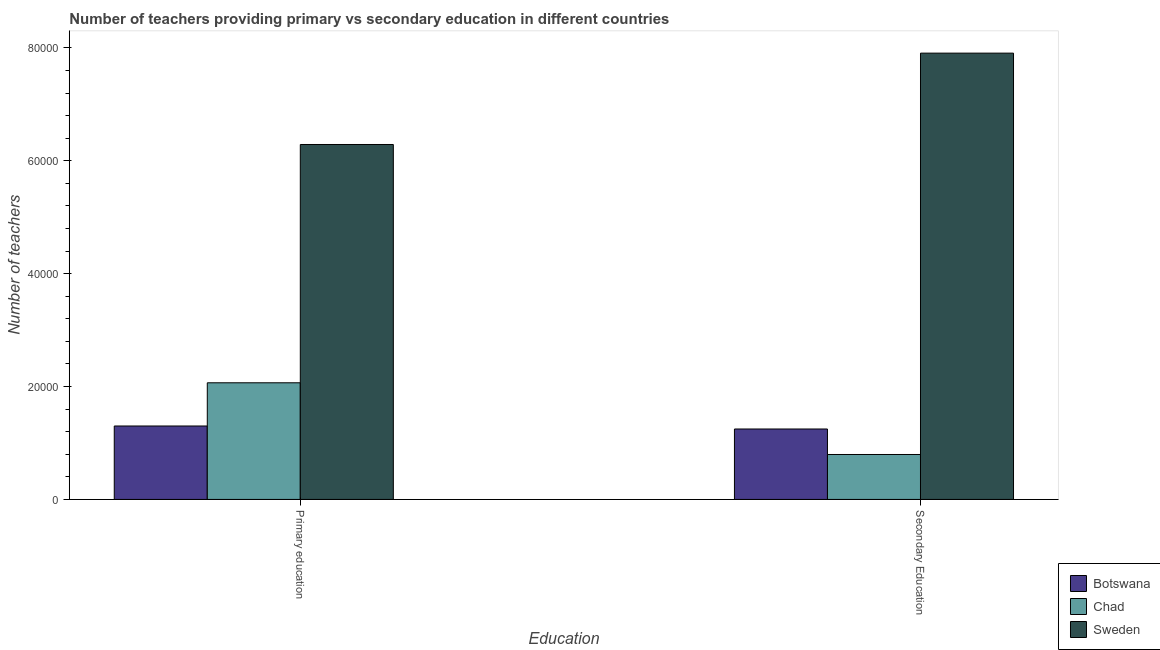How many groups of bars are there?
Provide a short and direct response. 2. Are the number of bars per tick equal to the number of legend labels?
Make the answer very short. Yes. How many bars are there on the 2nd tick from the left?
Keep it short and to the point. 3. What is the label of the 1st group of bars from the left?
Your response must be concise. Primary education. What is the number of secondary teachers in Chad?
Offer a very short reply. 7962. Across all countries, what is the maximum number of secondary teachers?
Make the answer very short. 7.91e+04. Across all countries, what is the minimum number of primary teachers?
Offer a terse response. 1.30e+04. In which country was the number of secondary teachers maximum?
Provide a succinct answer. Sweden. In which country was the number of primary teachers minimum?
Make the answer very short. Botswana. What is the total number of secondary teachers in the graph?
Provide a succinct answer. 9.95e+04. What is the difference between the number of primary teachers in Botswana and that in Chad?
Provide a short and direct response. -7658. What is the difference between the number of secondary teachers in Botswana and the number of primary teachers in Sweden?
Your response must be concise. -5.04e+04. What is the average number of primary teachers per country?
Make the answer very short. 3.22e+04. What is the difference between the number of secondary teachers and number of primary teachers in Chad?
Your response must be concise. -1.27e+04. In how many countries, is the number of secondary teachers greater than 64000 ?
Keep it short and to the point. 1. What is the ratio of the number of primary teachers in Chad to that in Sweden?
Ensure brevity in your answer.  0.33. Is the number of secondary teachers in Botswana less than that in Sweden?
Your response must be concise. Yes. What does the 1st bar from the left in Secondary Education represents?
Offer a very short reply. Botswana. What does the 3rd bar from the right in Secondary Education represents?
Your answer should be compact. Botswana. Are all the bars in the graph horizontal?
Your response must be concise. No. Does the graph contain grids?
Ensure brevity in your answer.  No. Where does the legend appear in the graph?
Offer a terse response. Bottom right. What is the title of the graph?
Provide a short and direct response. Number of teachers providing primary vs secondary education in different countries. Does "Greenland" appear as one of the legend labels in the graph?
Offer a terse response. No. What is the label or title of the X-axis?
Provide a succinct answer. Education. What is the label or title of the Y-axis?
Make the answer very short. Number of teachers. What is the Number of teachers in Botswana in Primary education?
Your answer should be compact. 1.30e+04. What is the Number of teachers in Chad in Primary education?
Offer a very short reply. 2.07e+04. What is the Number of teachers of Sweden in Primary education?
Your response must be concise. 6.29e+04. What is the Number of teachers of Botswana in Secondary Education?
Your answer should be compact. 1.25e+04. What is the Number of teachers in Chad in Secondary Education?
Give a very brief answer. 7962. What is the Number of teachers of Sweden in Secondary Education?
Offer a very short reply. 7.91e+04. Across all Education, what is the maximum Number of teachers in Botswana?
Offer a terse response. 1.30e+04. Across all Education, what is the maximum Number of teachers in Chad?
Your answer should be very brief. 2.07e+04. Across all Education, what is the maximum Number of teachers in Sweden?
Your response must be concise. 7.91e+04. Across all Education, what is the minimum Number of teachers of Botswana?
Ensure brevity in your answer.  1.25e+04. Across all Education, what is the minimum Number of teachers of Chad?
Offer a very short reply. 7962. Across all Education, what is the minimum Number of teachers in Sweden?
Provide a succinct answer. 6.29e+04. What is the total Number of teachers in Botswana in the graph?
Your answer should be compact. 2.55e+04. What is the total Number of teachers of Chad in the graph?
Offer a very short reply. 2.86e+04. What is the total Number of teachers in Sweden in the graph?
Keep it short and to the point. 1.42e+05. What is the difference between the Number of teachers in Botswana in Primary education and that in Secondary Education?
Provide a short and direct response. 531. What is the difference between the Number of teachers of Chad in Primary education and that in Secondary Education?
Provide a short and direct response. 1.27e+04. What is the difference between the Number of teachers of Sweden in Primary education and that in Secondary Education?
Offer a terse response. -1.62e+04. What is the difference between the Number of teachers of Botswana in Primary education and the Number of teachers of Chad in Secondary Education?
Your response must be concise. 5050. What is the difference between the Number of teachers of Botswana in Primary education and the Number of teachers of Sweden in Secondary Education?
Provide a short and direct response. -6.61e+04. What is the difference between the Number of teachers of Chad in Primary education and the Number of teachers of Sweden in Secondary Education?
Offer a very short reply. -5.84e+04. What is the average Number of teachers of Botswana per Education?
Provide a short and direct response. 1.27e+04. What is the average Number of teachers in Chad per Education?
Offer a terse response. 1.43e+04. What is the average Number of teachers in Sweden per Education?
Give a very brief answer. 7.10e+04. What is the difference between the Number of teachers in Botswana and Number of teachers in Chad in Primary education?
Keep it short and to the point. -7658. What is the difference between the Number of teachers in Botswana and Number of teachers in Sweden in Primary education?
Offer a very short reply. -4.99e+04. What is the difference between the Number of teachers of Chad and Number of teachers of Sweden in Primary education?
Your response must be concise. -4.22e+04. What is the difference between the Number of teachers of Botswana and Number of teachers of Chad in Secondary Education?
Offer a terse response. 4519. What is the difference between the Number of teachers in Botswana and Number of teachers in Sweden in Secondary Education?
Make the answer very short. -6.66e+04. What is the difference between the Number of teachers of Chad and Number of teachers of Sweden in Secondary Education?
Keep it short and to the point. -7.11e+04. What is the ratio of the Number of teachers of Botswana in Primary education to that in Secondary Education?
Provide a succinct answer. 1.04. What is the ratio of the Number of teachers of Chad in Primary education to that in Secondary Education?
Offer a terse response. 2.6. What is the ratio of the Number of teachers of Sweden in Primary education to that in Secondary Education?
Provide a succinct answer. 0.8. What is the difference between the highest and the second highest Number of teachers of Botswana?
Make the answer very short. 531. What is the difference between the highest and the second highest Number of teachers in Chad?
Your answer should be compact. 1.27e+04. What is the difference between the highest and the second highest Number of teachers in Sweden?
Your response must be concise. 1.62e+04. What is the difference between the highest and the lowest Number of teachers of Botswana?
Provide a succinct answer. 531. What is the difference between the highest and the lowest Number of teachers of Chad?
Offer a very short reply. 1.27e+04. What is the difference between the highest and the lowest Number of teachers of Sweden?
Your answer should be compact. 1.62e+04. 